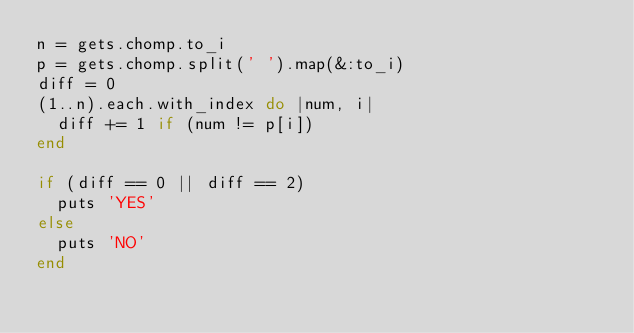<code> <loc_0><loc_0><loc_500><loc_500><_Ruby_>n = gets.chomp.to_i
p = gets.chomp.split(' ').map(&:to_i)
diff = 0
(1..n).each.with_index do |num, i|
  diff += 1 if (num != p[i])
end

if (diff == 0 || diff == 2)
  puts 'YES'
else
  puts 'NO'
end</code> 